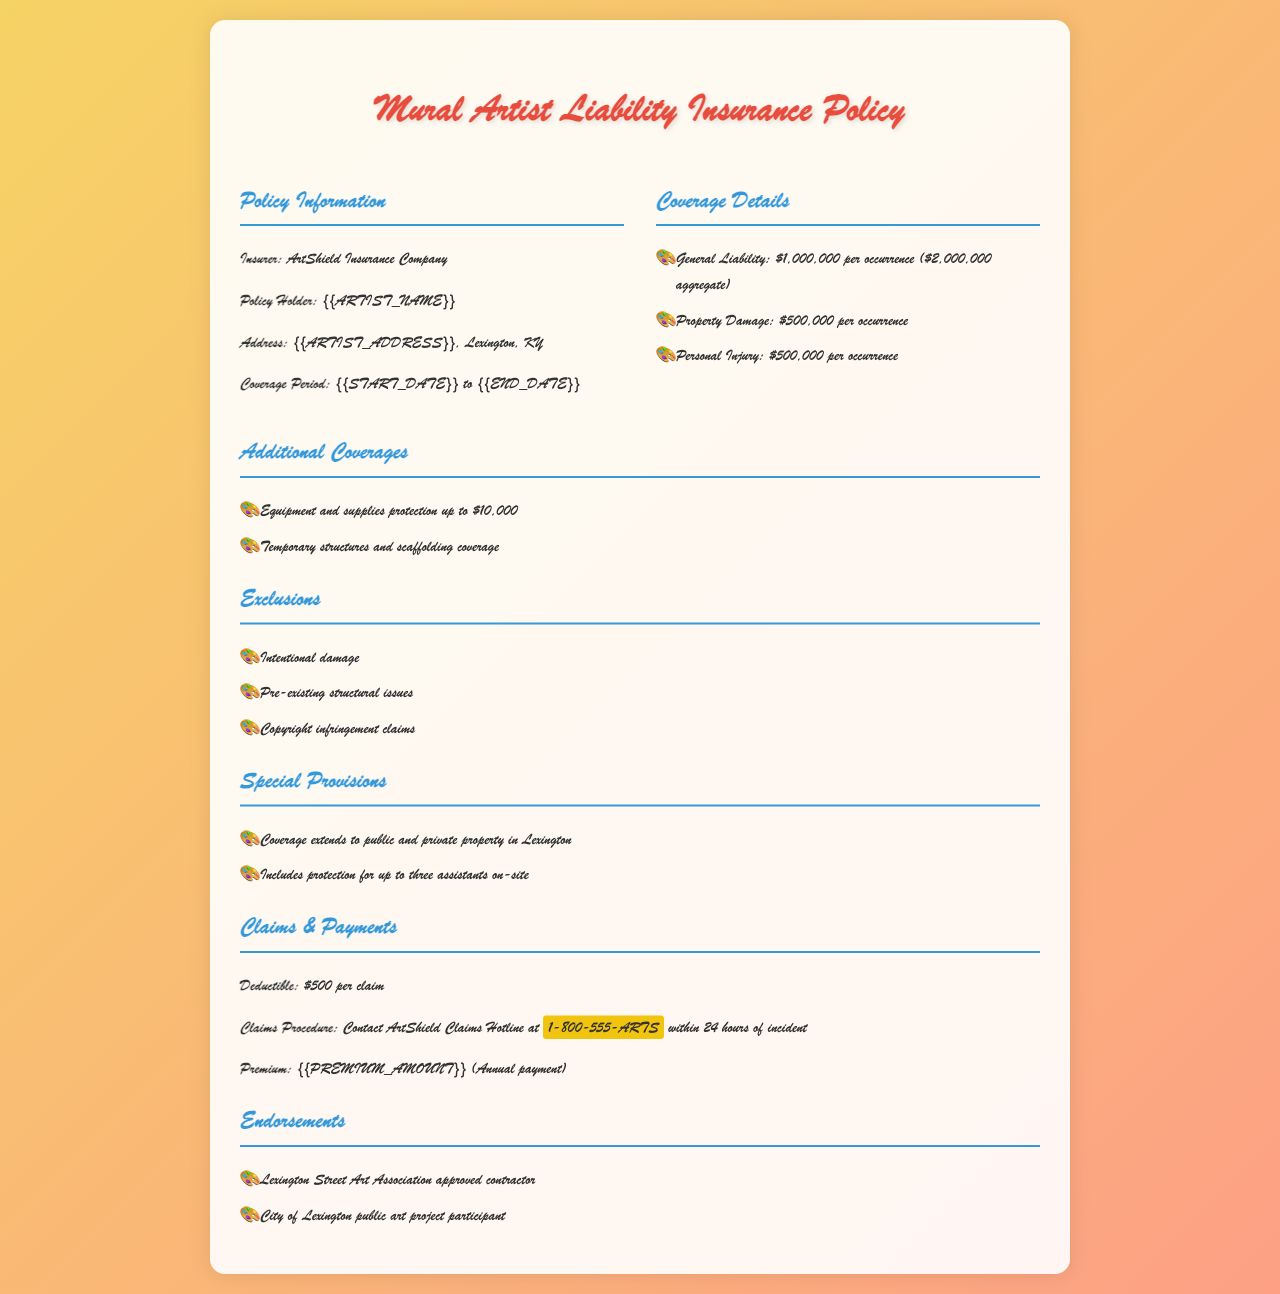what is the insurer's name? The insurer's name is stated in the policy information section of the document.
Answer: ArtShield Insurance Company what is the policyholder's address? The policyholder's address is found in the policy information section and includes the city and state.
Answer: {{ARTIST_ADDRESS}}, Lexington, KY what is the coverage period? The coverage period specifies the start and end dates for the insurance coverage.
Answer: {{START_DATE}} to {{END_DATE}} what is the deductible amount per claim? The deductible amount is specifically mentioned in the claims and payments section of the document.
Answer: $500 how much is the general liability coverage? The amount of general liability coverage is detailed under coverage details.
Answer: $1,000,000 per occurrence ($2,000,000 aggregate) what types of additional coverage are provided? The types of additional coverages can be listed in the respective section of the policy document.
Answer: Equipment and supplies protection up to $10,000; Temporary structures and scaffolding coverage what are the exclusions of the policy? The exclusions are outlined in a specific section of the document, listing what is not covered.
Answer: Intentional damage; Pre-existing structural issues; Copyright infringement claims how many assistants are covered on-site? The number of assistants covered is mentioned in the special provisions section.
Answer: Up to three assistants what is the annual premium amount? The annual premium amount is specifically mentioned in the claims and payments section.
Answer: {{PREMIUM_AMOUNT}} 